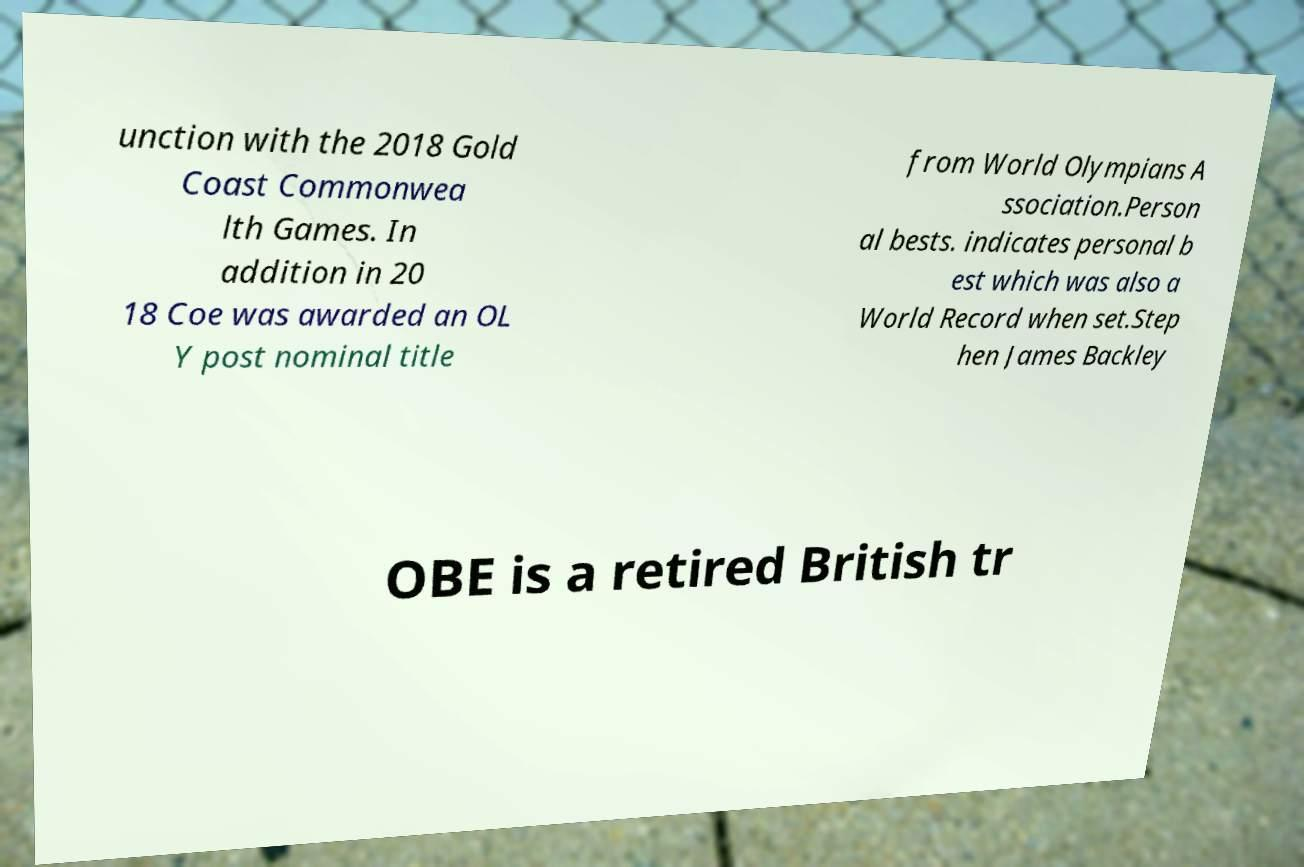Can you read and provide the text displayed in the image?This photo seems to have some interesting text. Can you extract and type it out for me? unction with the 2018 Gold Coast Commonwea lth Games. In addition in 20 18 Coe was awarded an OL Y post nominal title from World Olympians A ssociation.Person al bests. indicates personal b est which was also a World Record when set.Step hen James Backley OBE is a retired British tr 